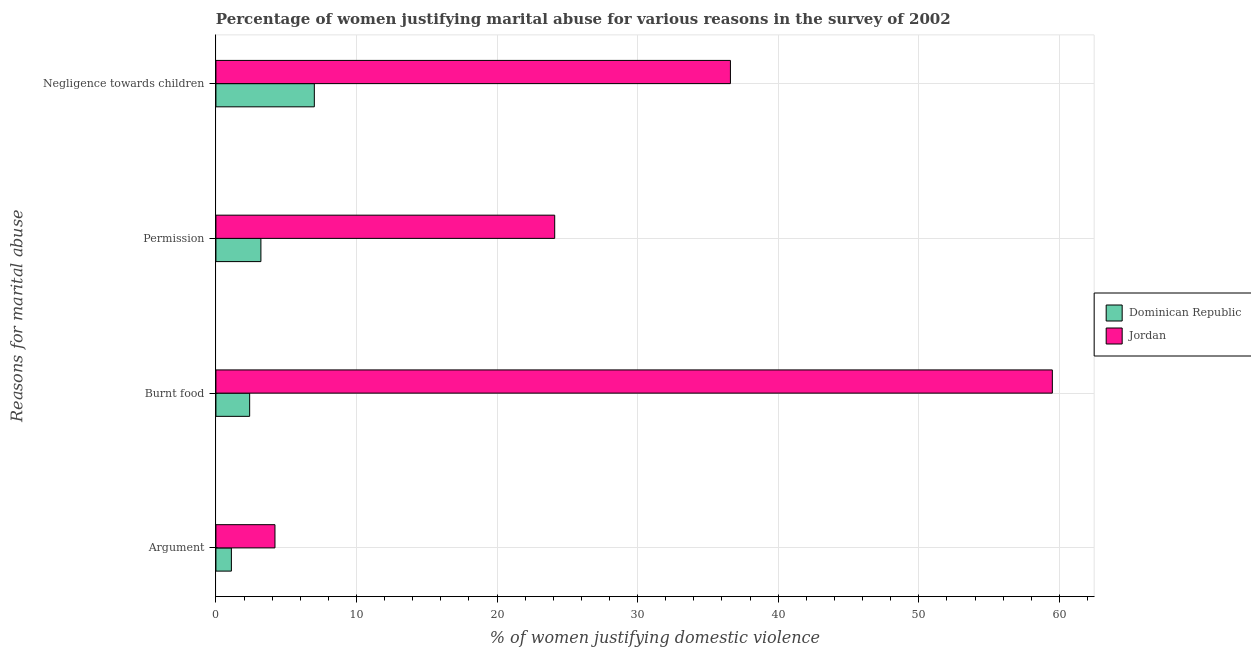How many different coloured bars are there?
Make the answer very short. 2. How many groups of bars are there?
Keep it short and to the point. 4. Are the number of bars on each tick of the Y-axis equal?
Offer a terse response. Yes. How many bars are there on the 2nd tick from the bottom?
Keep it short and to the point. 2. What is the label of the 3rd group of bars from the top?
Provide a succinct answer. Burnt food. Across all countries, what is the maximum percentage of women justifying abuse in the case of an argument?
Provide a short and direct response. 4.2. In which country was the percentage of women justifying abuse for going without permission maximum?
Provide a short and direct response. Jordan. In which country was the percentage of women justifying abuse in the case of an argument minimum?
Your answer should be compact. Dominican Republic. What is the total percentage of women justifying abuse for showing negligence towards children in the graph?
Provide a succinct answer. 43.6. What is the difference between the percentage of women justifying abuse for burning food in Dominican Republic and that in Jordan?
Offer a very short reply. -57.1. What is the average percentage of women justifying abuse for going without permission per country?
Give a very brief answer. 13.65. What is the difference between the percentage of women justifying abuse for showing negligence towards children and percentage of women justifying abuse for going without permission in Dominican Republic?
Offer a terse response. 3.8. What is the ratio of the percentage of women justifying abuse for going without permission in Jordan to that in Dominican Republic?
Provide a short and direct response. 7.53. Is the percentage of women justifying abuse for showing negligence towards children in Jordan less than that in Dominican Republic?
Your response must be concise. No. What is the difference between the highest and the second highest percentage of women justifying abuse for going without permission?
Offer a very short reply. 20.9. What is the difference between the highest and the lowest percentage of women justifying abuse for showing negligence towards children?
Provide a short and direct response. 29.6. In how many countries, is the percentage of women justifying abuse for showing negligence towards children greater than the average percentage of women justifying abuse for showing negligence towards children taken over all countries?
Your answer should be very brief. 1. Is it the case that in every country, the sum of the percentage of women justifying abuse for burning food and percentage of women justifying abuse for showing negligence towards children is greater than the sum of percentage of women justifying abuse in the case of an argument and percentage of women justifying abuse for going without permission?
Keep it short and to the point. Yes. What does the 1st bar from the top in Negligence towards children represents?
Make the answer very short. Jordan. What does the 2nd bar from the bottom in Negligence towards children represents?
Keep it short and to the point. Jordan. Is it the case that in every country, the sum of the percentage of women justifying abuse in the case of an argument and percentage of women justifying abuse for burning food is greater than the percentage of women justifying abuse for going without permission?
Your answer should be compact. Yes. What is the difference between two consecutive major ticks on the X-axis?
Provide a short and direct response. 10. Does the graph contain grids?
Your answer should be very brief. Yes. How many legend labels are there?
Provide a succinct answer. 2. What is the title of the graph?
Provide a short and direct response. Percentage of women justifying marital abuse for various reasons in the survey of 2002. What is the label or title of the X-axis?
Ensure brevity in your answer.  % of women justifying domestic violence. What is the label or title of the Y-axis?
Make the answer very short. Reasons for marital abuse. What is the % of women justifying domestic violence in Jordan in Argument?
Give a very brief answer. 4.2. What is the % of women justifying domestic violence in Jordan in Burnt food?
Offer a very short reply. 59.5. What is the % of women justifying domestic violence of Dominican Republic in Permission?
Make the answer very short. 3.2. What is the % of women justifying domestic violence of Jordan in Permission?
Offer a very short reply. 24.1. What is the % of women justifying domestic violence in Jordan in Negligence towards children?
Your answer should be very brief. 36.6. Across all Reasons for marital abuse, what is the maximum % of women justifying domestic violence in Jordan?
Offer a very short reply. 59.5. Across all Reasons for marital abuse, what is the minimum % of women justifying domestic violence in Dominican Republic?
Your answer should be very brief. 1.1. Across all Reasons for marital abuse, what is the minimum % of women justifying domestic violence in Jordan?
Offer a terse response. 4.2. What is the total % of women justifying domestic violence in Jordan in the graph?
Your answer should be very brief. 124.4. What is the difference between the % of women justifying domestic violence in Dominican Republic in Argument and that in Burnt food?
Ensure brevity in your answer.  -1.3. What is the difference between the % of women justifying domestic violence in Jordan in Argument and that in Burnt food?
Offer a terse response. -55.3. What is the difference between the % of women justifying domestic violence in Jordan in Argument and that in Permission?
Provide a short and direct response. -19.9. What is the difference between the % of women justifying domestic violence of Jordan in Argument and that in Negligence towards children?
Make the answer very short. -32.4. What is the difference between the % of women justifying domestic violence in Jordan in Burnt food and that in Permission?
Make the answer very short. 35.4. What is the difference between the % of women justifying domestic violence in Jordan in Burnt food and that in Negligence towards children?
Ensure brevity in your answer.  22.9. What is the difference between the % of women justifying domestic violence in Dominican Republic in Permission and that in Negligence towards children?
Give a very brief answer. -3.8. What is the difference between the % of women justifying domestic violence of Jordan in Permission and that in Negligence towards children?
Your answer should be very brief. -12.5. What is the difference between the % of women justifying domestic violence in Dominican Republic in Argument and the % of women justifying domestic violence in Jordan in Burnt food?
Offer a very short reply. -58.4. What is the difference between the % of women justifying domestic violence in Dominican Republic in Argument and the % of women justifying domestic violence in Jordan in Negligence towards children?
Make the answer very short. -35.5. What is the difference between the % of women justifying domestic violence of Dominican Republic in Burnt food and the % of women justifying domestic violence of Jordan in Permission?
Give a very brief answer. -21.7. What is the difference between the % of women justifying domestic violence in Dominican Republic in Burnt food and the % of women justifying domestic violence in Jordan in Negligence towards children?
Your answer should be very brief. -34.2. What is the difference between the % of women justifying domestic violence of Dominican Republic in Permission and the % of women justifying domestic violence of Jordan in Negligence towards children?
Offer a terse response. -33.4. What is the average % of women justifying domestic violence of Dominican Republic per Reasons for marital abuse?
Offer a terse response. 3.42. What is the average % of women justifying domestic violence in Jordan per Reasons for marital abuse?
Provide a succinct answer. 31.1. What is the difference between the % of women justifying domestic violence of Dominican Republic and % of women justifying domestic violence of Jordan in Argument?
Your answer should be very brief. -3.1. What is the difference between the % of women justifying domestic violence in Dominican Republic and % of women justifying domestic violence in Jordan in Burnt food?
Provide a short and direct response. -57.1. What is the difference between the % of women justifying domestic violence of Dominican Republic and % of women justifying domestic violence of Jordan in Permission?
Offer a very short reply. -20.9. What is the difference between the % of women justifying domestic violence of Dominican Republic and % of women justifying domestic violence of Jordan in Negligence towards children?
Give a very brief answer. -29.6. What is the ratio of the % of women justifying domestic violence in Dominican Republic in Argument to that in Burnt food?
Offer a very short reply. 0.46. What is the ratio of the % of women justifying domestic violence of Jordan in Argument to that in Burnt food?
Your answer should be very brief. 0.07. What is the ratio of the % of women justifying domestic violence in Dominican Republic in Argument to that in Permission?
Ensure brevity in your answer.  0.34. What is the ratio of the % of women justifying domestic violence of Jordan in Argument to that in Permission?
Keep it short and to the point. 0.17. What is the ratio of the % of women justifying domestic violence in Dominican Republic in Argument to that in Negligence towards children?
Offer a very short reply. 0.16. What is the ratio of the % of women justifying domestic violence of Jordan in Argument to that in Negligence towards children?
Ensure brevity in your answer.  0.11. What is the ratio of the % of women justifying domestic violence in Dominican Republic in Burnt food to that in Permission?
Your response must be concise. 0.75. What is the ratio of the % of women justifying domestic violence in Jordan in Burnt food to that in Permission?
Your answer should be very brief. 2.47. What is the ratio of the % of women justifying domestic violence of Dominican Republic in Burnt food to that in Negligence towards children?
Keep it short and to the point. 0.34. What is the ratio of the % of women justifying domestic violence in Jordan in Burnt food to that in Negligence towards children?
Your answer should be very brief. 1.63. What is the ratio of the % of women justifying domestic violence in Dominican Republic in Permission to that in Negligence towards children?
Keep it short and to the point. 0.46. What is the ratio of the % of women justifying domestic violence of Jordan in Permission to that in Negligence towards children?
Offer a very short reply. 0.66. What is the difference between the highest and the second highest % of women justifying domestic violence in Dominican Republic?
Provide a succinct answer. 3.8. What is the difference between the highest and the second highest % of women justifying domestic violence in Jordan?
Provide a short and direct response. 22.9. What is the difference between the highest and the lowest % of women justifying domestic violence of Dominican Republic?
Make the answer very short. 5.9. What is the difference between the highest and the lowest % of women justifying domestic violence in Jordan?
Give a very brief answer. 55.3. 